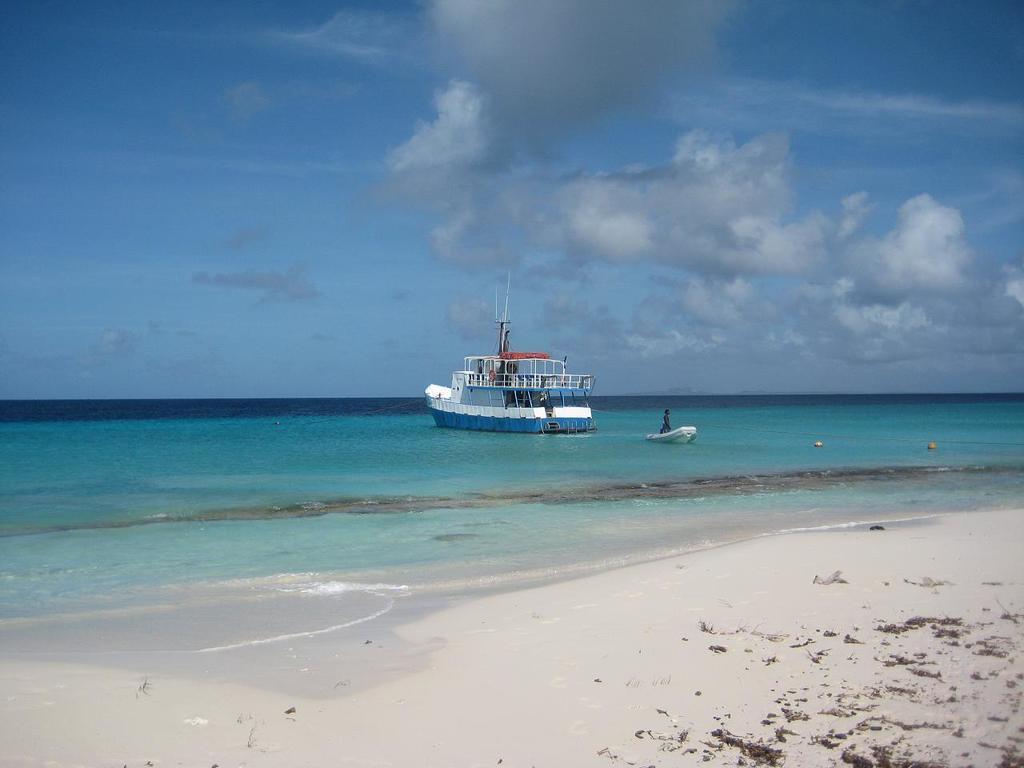Could you give a brief overview of what you see in this image? In the middle I can see two boats and a person in the water. In the background I can see the sky. This image is taken may be on the sandy beach. 